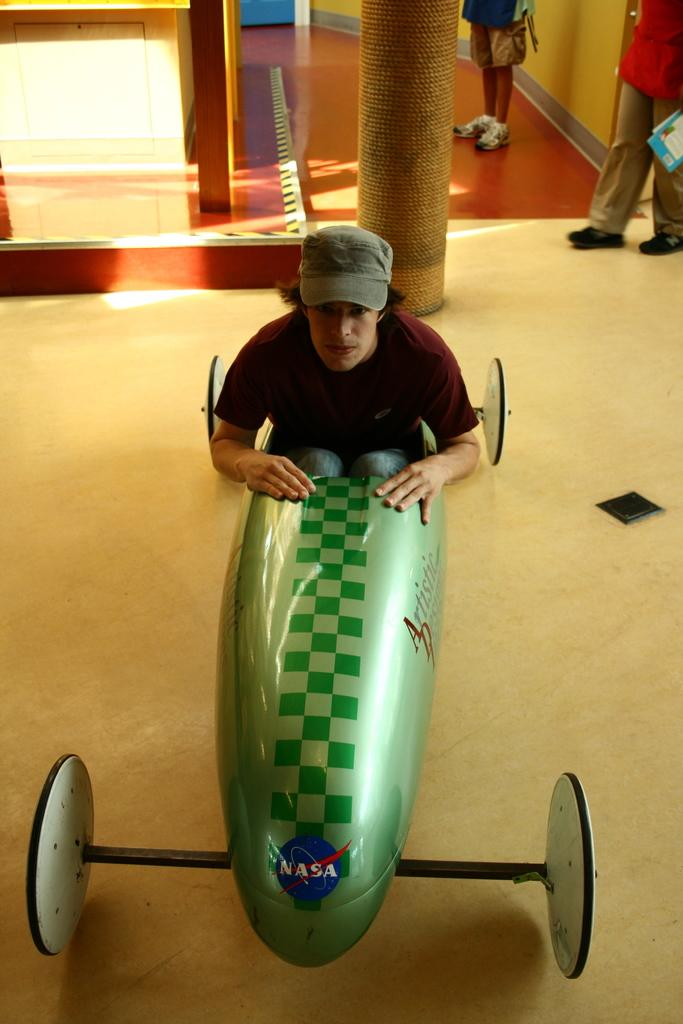Provide a one-sentence caption for the provided image. Man in a NASA car roaming around with people looking on. 